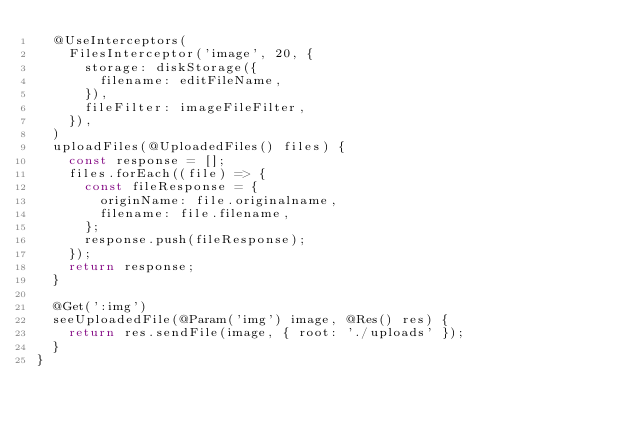Convert code to text. <code><loc_0><loc_0><loc_500><loc_500><_TypeScript_>  @UseInterceptors(
    FilesInterceptor('image', 20, {
      storage: diskStorage({
        filename: editFileName,
      }),
      fileFilter: imageFileFilter,
    }),
  )
  uploadFiles(@UploadedFiles() files) {
    const response = [];
    files.forEach((file) => {
      const fileResponse = {
        originName: file.originalname,
        filename: file.filename,
      };
      response.push(fileResponse);
    });
    return response;
  }

  @Get(':img')
  seeUploadedFile(@Param('img') image, @Res() res) {
    return res.sendFile(image, { root: './uploads' });
  }
}
</code> 